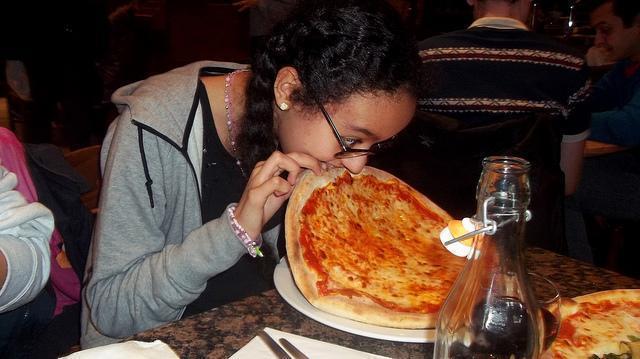What would most people do first before biting their pizza?
Make your selection from the four choices given to correctly answer the question.
Options: Slice it, ice it, dress it, cool it. Slice it. What direction are the stripes on the person's shirt going?
Select the accurate answer and provide explanation: 'Answer: answer
Rationale: rationale.'
Options: Vertical, horizontal, diagonal, intersected. Answer: horizontal.
Rationale: The stripes are going from side to side and not up and down 